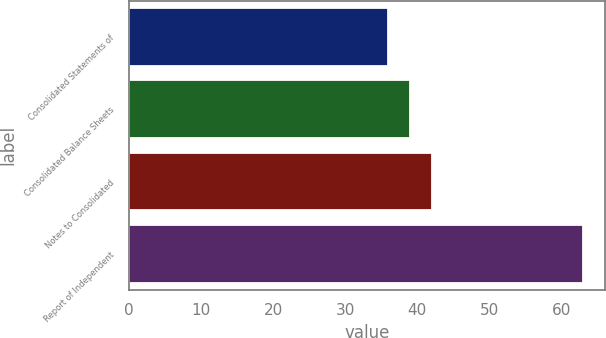Convert chart. <chart><loc_0><loc_0><loc_500><loc_500><bar_chart><fcel>Consolidated Statements of<fcel>Consolidated Balance Sheets<fcel>Notes to Consolidated<fcel>Report of Independent<nl><fcel>36<fcel>39<fcel>42<fcel>63<nl></chart> 